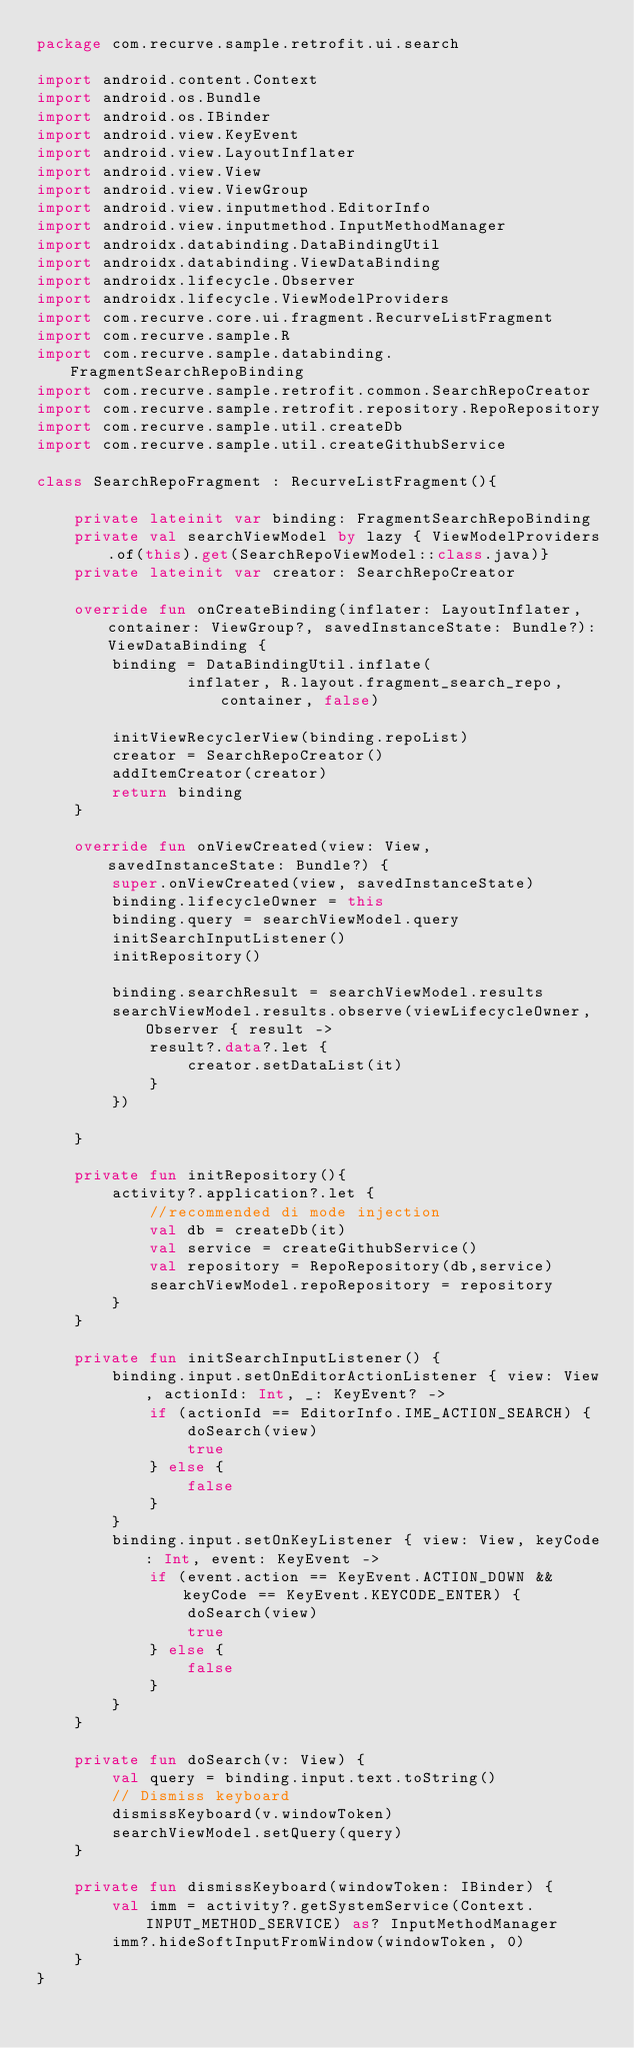<code> <loc_0><loc_0><loc_500><loc_500><_Kotlin_>package com.recurve.sample.retrofit.ui.search

import android.content.Context
import android.os.Bundle
import android.os.IBinder
import android.view.KeyEvent
import android.view.LayoutInflater
import android.view.View
import android.view.ViewGroup
import android.view.inputmethod.EditorInfo
import android.view.inputmethod.InputMethodManager
import androidx.databinding.DataBindingUtil
import androidx.databinding.ViewDataBinding
import androidx.lifecycle.Observer
import androidx.lifecycle.ViewModelProviders
import com.recurve.core.ui.fragment.RecurveListFragment
import com.recurve.sample.R
import com.recurve.sample.databinding.FragmentSearchRepoBinding
import com.recurve.sample.retrofit.common.SearchRepoCreator
import com.recurve.sample.retrofit.repository.RepoRepository
import com.recurve.sample.util.createDb
import com.recurve.sample.util.createGithubService

class SearchRepoFragment : RecurveListFragment(){

    private lateinit var binding: FragmentSearchRepoBinding
    private val searchViewModel by lazy { ViewModelProviders.of(this).get(SearchRepoViewModel::class.java)}
    private lateinit var creator: SearchRepoCreator

    override fun onCreateBinding(inflater: LayoutInflater, container: ViewGroup?, savedInstanceState: Bundle?): ViewDataBinding {
        binding = DataBindingUtil.inflate(
                inflater, R.layout.fragment_search_repo, container, false)

        initViewRecyclerView(binding.repoList)
        creator = SearchRepoCreator()
        addItemCreator(creator)
        return binding
    }

    override fun onViewCreated(view: View, savedInstanceState: Bundle?) {
        super.onViewCreated(view, savedInstanceState)
        binding.lifecycleOwner = this
        binding.query = searchViewModel.query
        initSearchInputListener()
        initRepository()

        binding.searchResult = searchViewModel.results
        searchViewModel.results.observe(viewLifecycleOwner, Observer { result ->
            result?.data?.let {
                creator.setDataList(it)
            }
        })

    }

    private fun initRepository(){
        activity?.application?.let {
            //recommended di mode injection
            val db = createDb(it)
            val service = createGithubService()
            val repository = RepoRepository(db,service)
            searchViewModel.repoRepository = repository
        }
    }

    private fun initSearchInputListener() {
        binding.input.setOnEditorActionListener { view: View, actionId: Int, _: KeyEvent? ->
            if (actionId == EditorInfo.IME_ACTION_SEARCH) {
                doSearch(view)
                true
            } else {
                false
            }
        }
        binding.input.setOnKeyListener { view: View, keyCode: Int, event: KeyEvent ->
            if (event.action == KeyEvent.ACTION_DOWN && keyCode == KeyEvent.KEYCODE_ENTER) {
                doSearch(view)
                true
            } else {
                false
            }
        }
    }

    private fun doSearch(v: View) {
        val query = binding.input.text.toString()
        // Dismiss keyboard
        dismissKeyboard(v.windowToken)
        searchViewModel.setQuery(query)
    }

    private fun dismissKeyboard(windowToken: IBinder) {
        val imm = activity?.getSystemService(Context.INPUT_METHOD_SERVICE) as? InputMethodManager
        imm?.hideSoftInputFromWindow(windowToken, 0)
    }
}</code> 